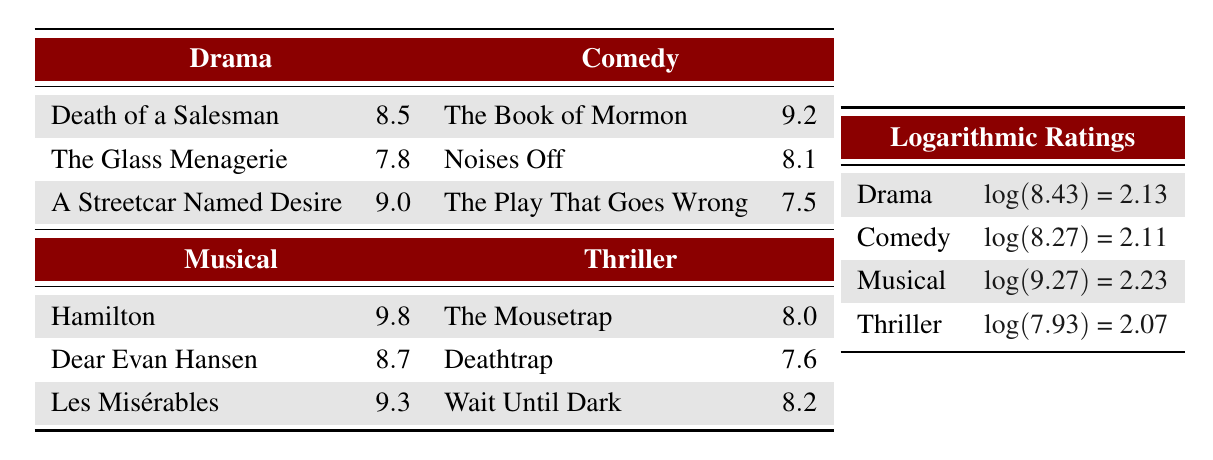What is the highest rating among the drama plays? The highest rating in the drama category is found in the play "A Streetcar Named Desire," which has a rating of 9.0.
Answer: 9.0 Which comedy play has the lowest rating? The play with the lowest rating in the comedy category is "The Play That Goes Wrong," which has a rating of 7.5.
Answer: 7.5 What is the average rating of the musical performances? To find the average, sum the ratings of the musical plays (9.8 + 8.7 + 9.3 = 27.8) and divide by the number of plays (3). The average rating is 27.8 / 3 = 9.27.
Answer: 9.27 Is "Deathtrap" rated higher than "Wait Until Dark"? "Deathtrap" has a rating of 7.6, while "Wait Until Dark" has a rating of 8.2. Since 7.6 is less than 8.2, it is false that "Deathtrap" is rated higher.
Answer: No What is the total rating of all the comedy plays combined? To find the total rating for the comedy plays, add the ratings together: 9.2 + 8.1 + 7.5 = 24.8.
Answer: 24.8 Which genre has the highest logarithmic rating? The logarithmic ratings provided are Drama (2.13), Comedy (2.11), Musical (2.23), Thriller (2.07). Comparing these, Musical has the highest logarithmic rating of 2.23.
Answer: Musical What is the difference between the highest-rated musical and the highest-rated drama? The highest-rated musical is "Hamilton" at 9.8, and the highest-rated drama is "A Streetcar Named Desire" at 9.0. The difference is 9.8 - 9.0 = 0.8.
Answer: 0.8 Do all the comedy plays have ratings above 7.0? The comedy plays have ratings of 9.2, 8.1, and 7.5. Since 7.5 is below 7.0, it is false that all comedy plays have ratings above 7.0.
Answer: No 